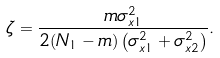Convert formula to latex. <formula><loc_0><loc_0><loc_500><loc_500>\zeta = \frac { m \sigma _ { x 1 } ^ { 2 } } { 2 ( N _ { 1 } - m ) \left ( \sigma _ { x 1 } ^ { 2 } + \sigma _ { x 2 } ^ { 2 } \right ) } .</formula> 